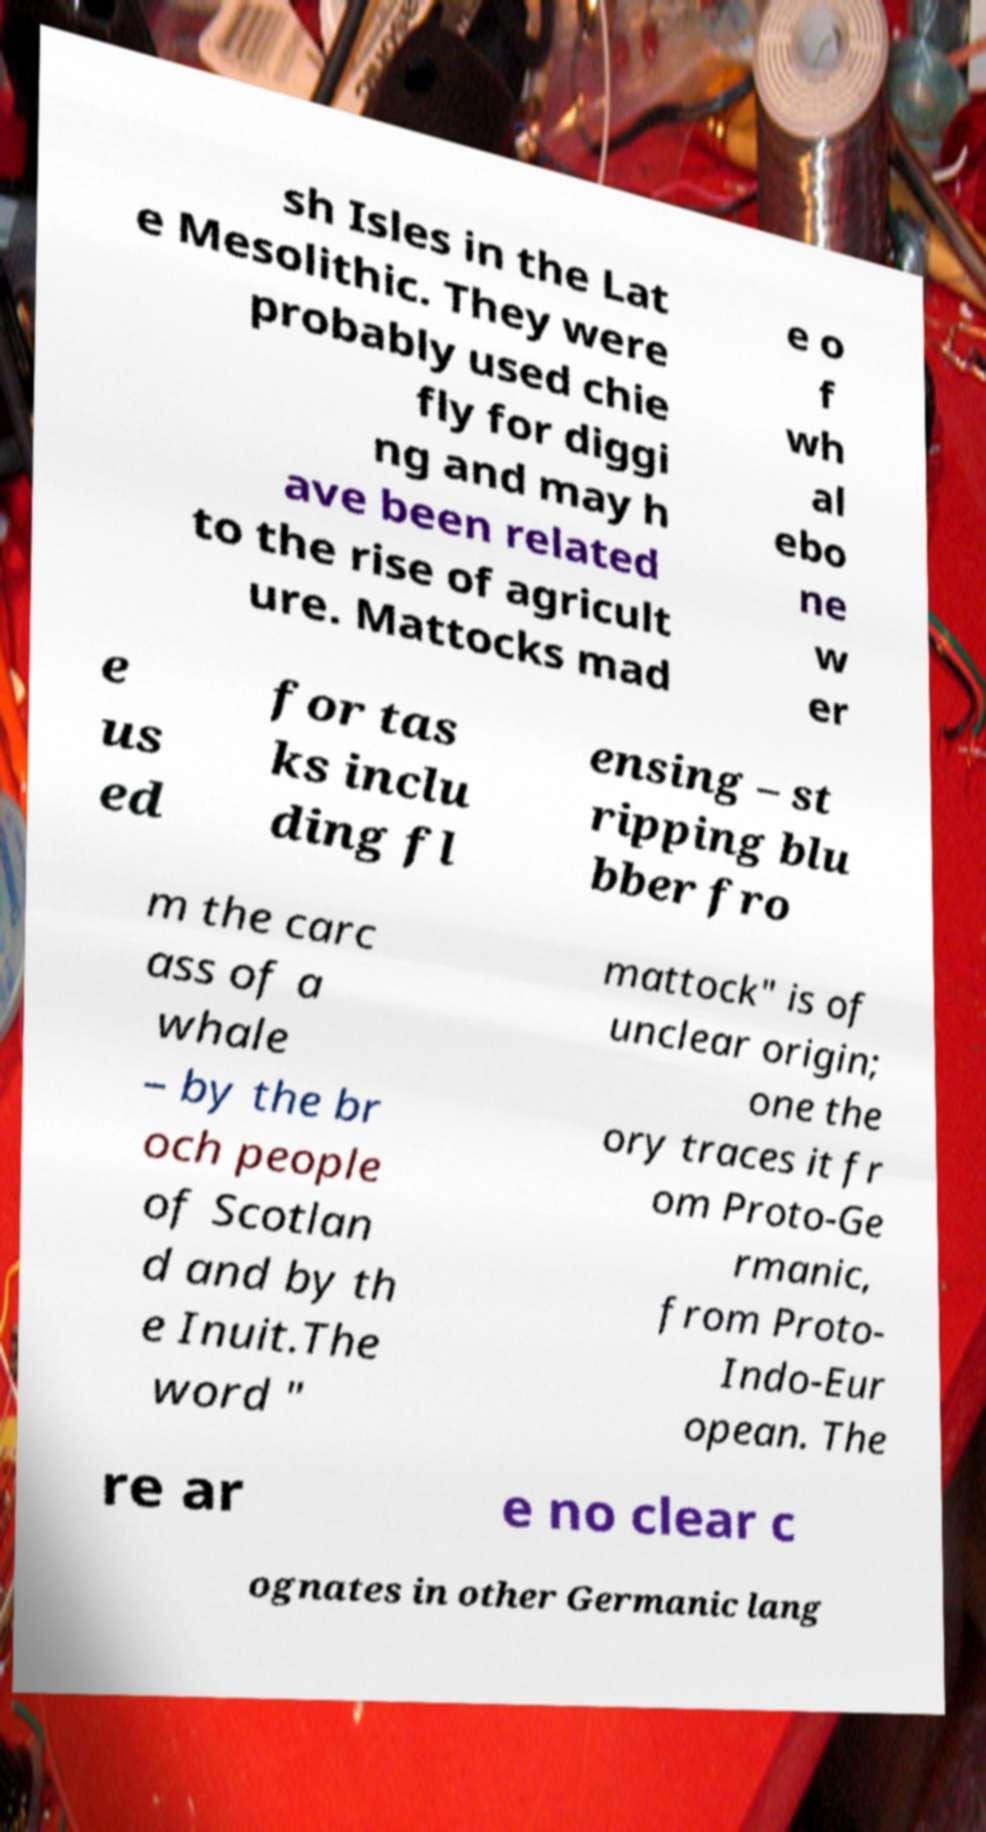Can you accurately transcribe the text from the provided image for me? sh Isles in the Lat e Mesolithic. They were probably used chie fly for diggi ng and may h ave been related to the rise of agricult ure. Mattocks mad e o f wh al ebo ne w er e us ed for tas ks inclu ding fl ensing – st ripping blu bber fro m the carc ass of a whale – by the br och people of Scotlan d and by th e Inuit.The word " mattock" is of unclear origin; one the ory traces it fr om Proto-Ge rmanic, from Proto- Indo-Eur opean. The re ar e no clear c ognates in other Germanic lang 